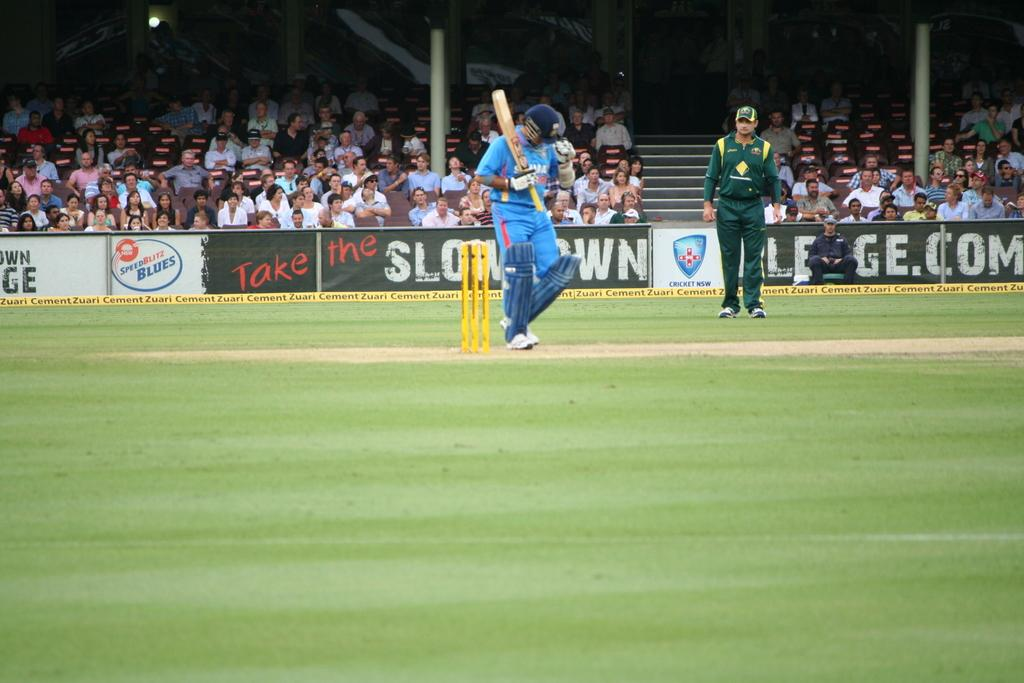<image>
Present a compact description of the photo's key features. A cricket game with an advertisement for SpeedBlitz Blues on the wall. 